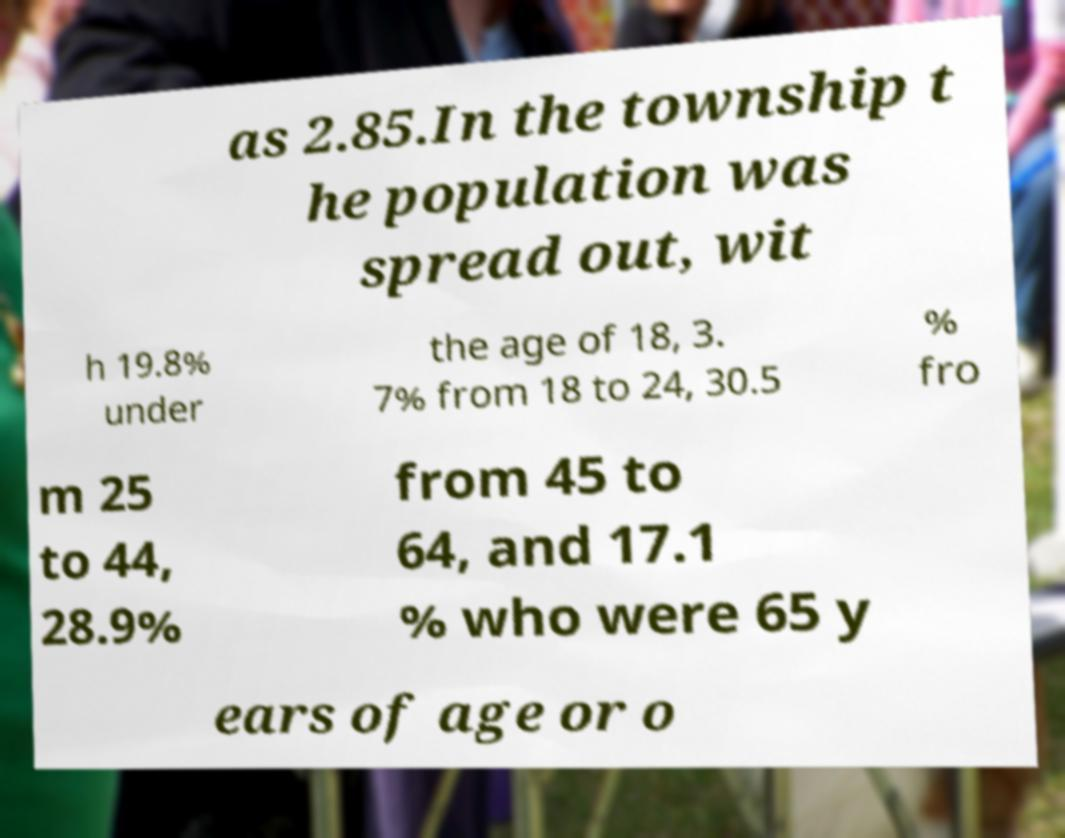I need the written content from this picture converted into text. Can you do that? as 2.85.In the township t he population was spread out, wit h 19.8% under the age of 18, 3. 7% from 18 to 24, 30.5 % fro m 25 to 44, 28.9% from 45 to 64, and 17.1 % who were 65 y ears of age or o 